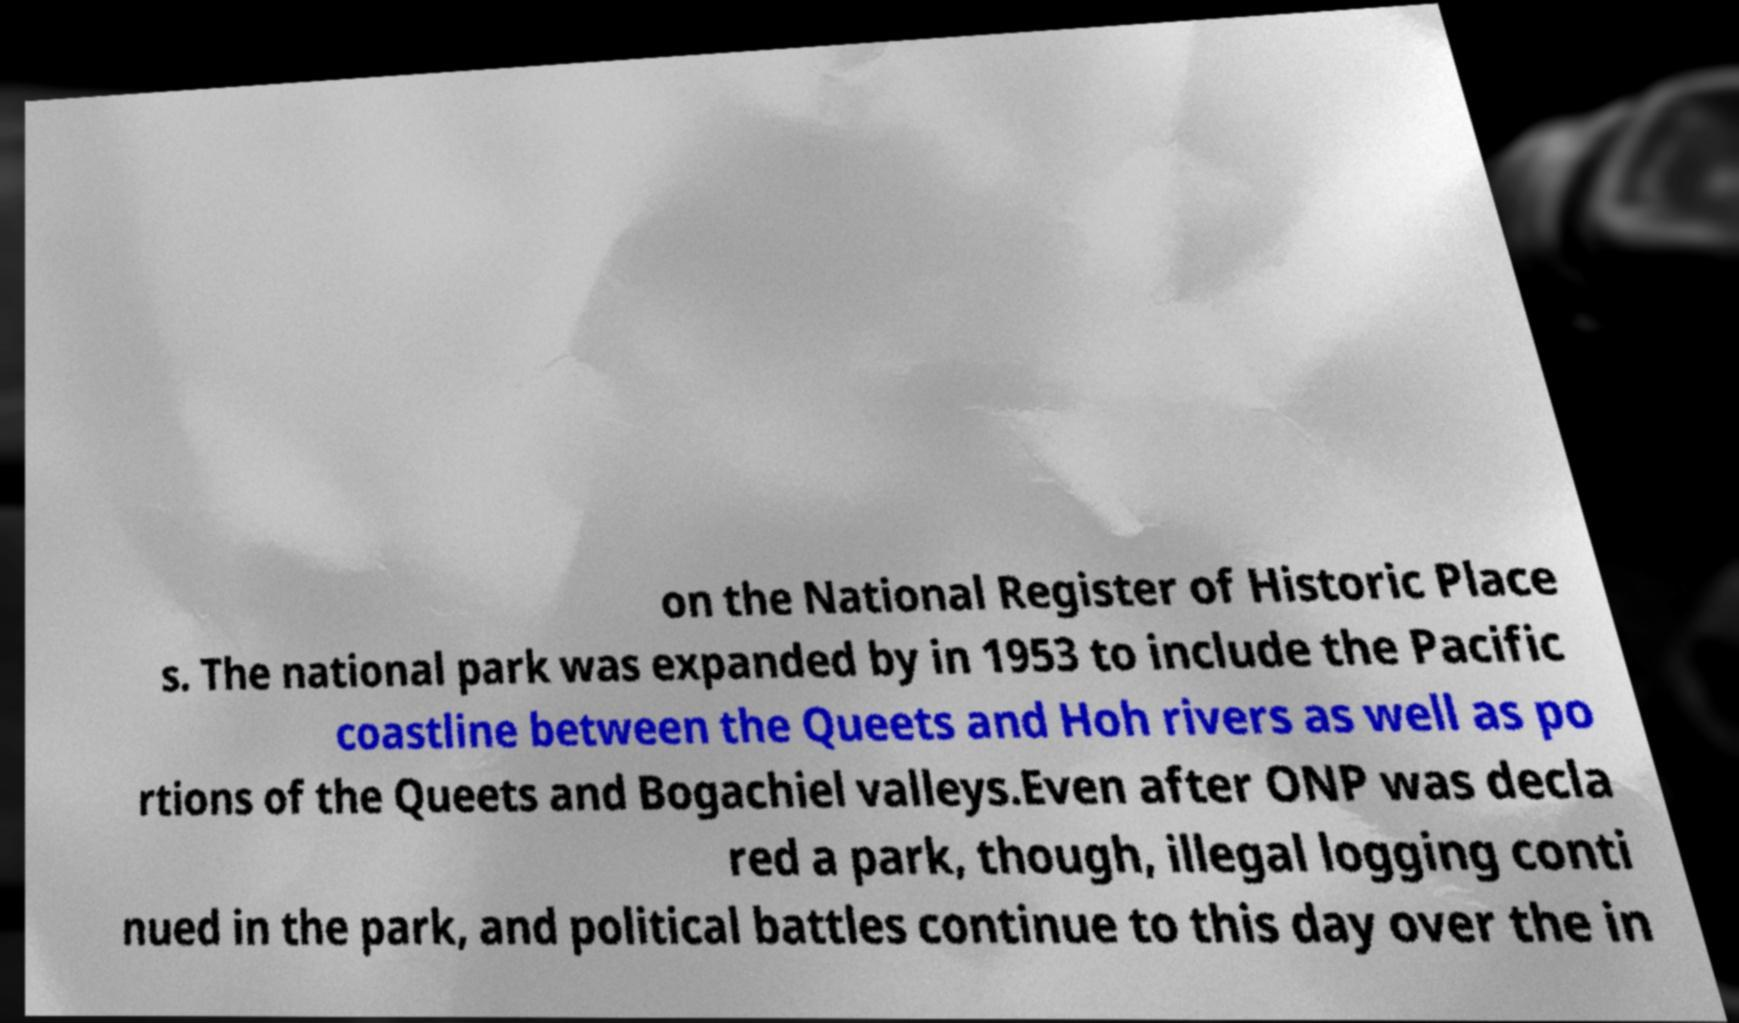Can you read and provide the text displayed in the image?This photo seems to have some interesting text. Can you extract and type it out for me? on the National Register of Historic Place s. The national park was expanded by in 1953 to include the Pacific coastline between the Queets and Hoh rivers as well as po rtions of the Queets and Bogachiel valleys.Even after ONP was decla red a park, though, illegal logging conti nued in the park, and political battles continue to this day over the in 